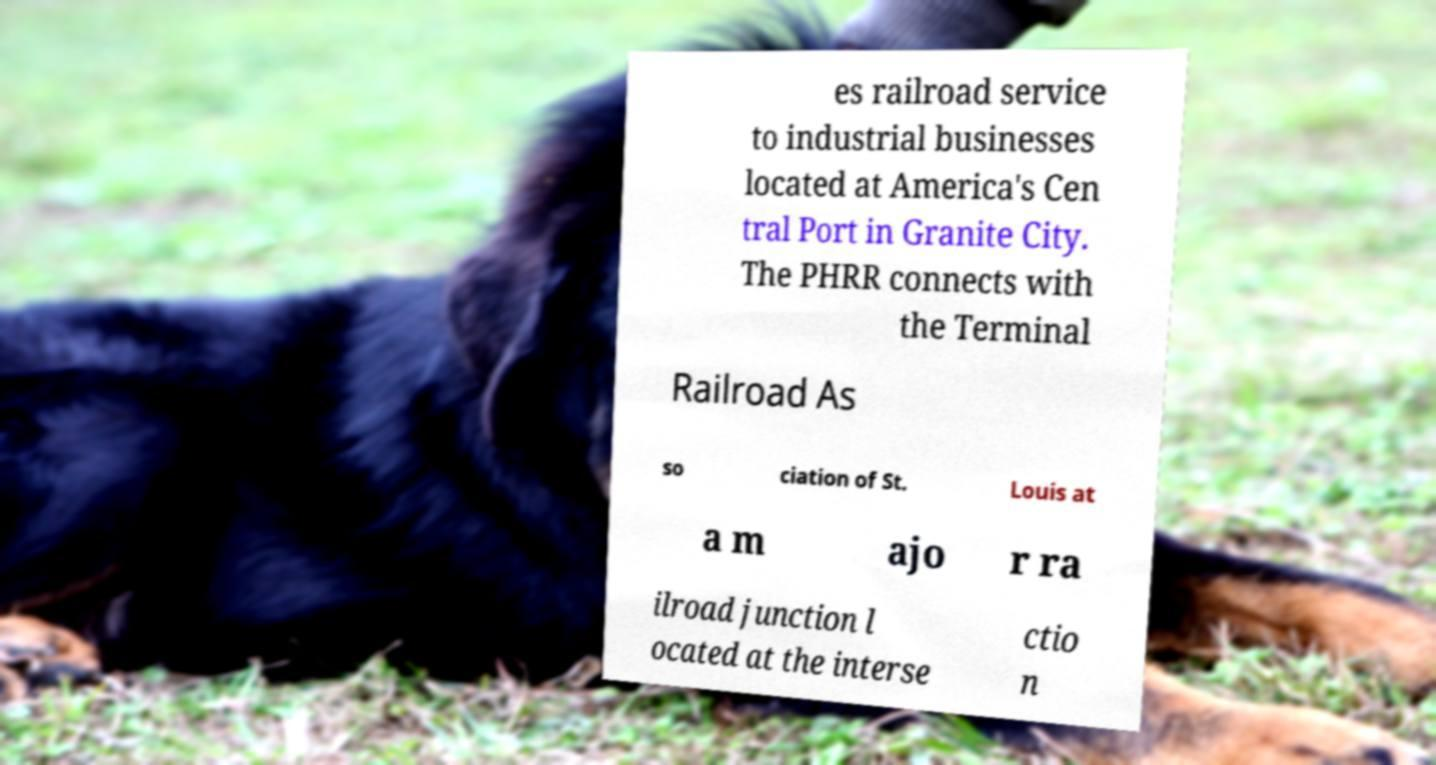Please read and relay the text visible in this image. What does it say? es railroad service to industrial businesses located at America's Cen tral Port in Granite City. The PHRR connects with the Terminal Railroad As so ciation of St. Louis at a m ajo r ra ilroad junction l ocated at the interse ctio n 